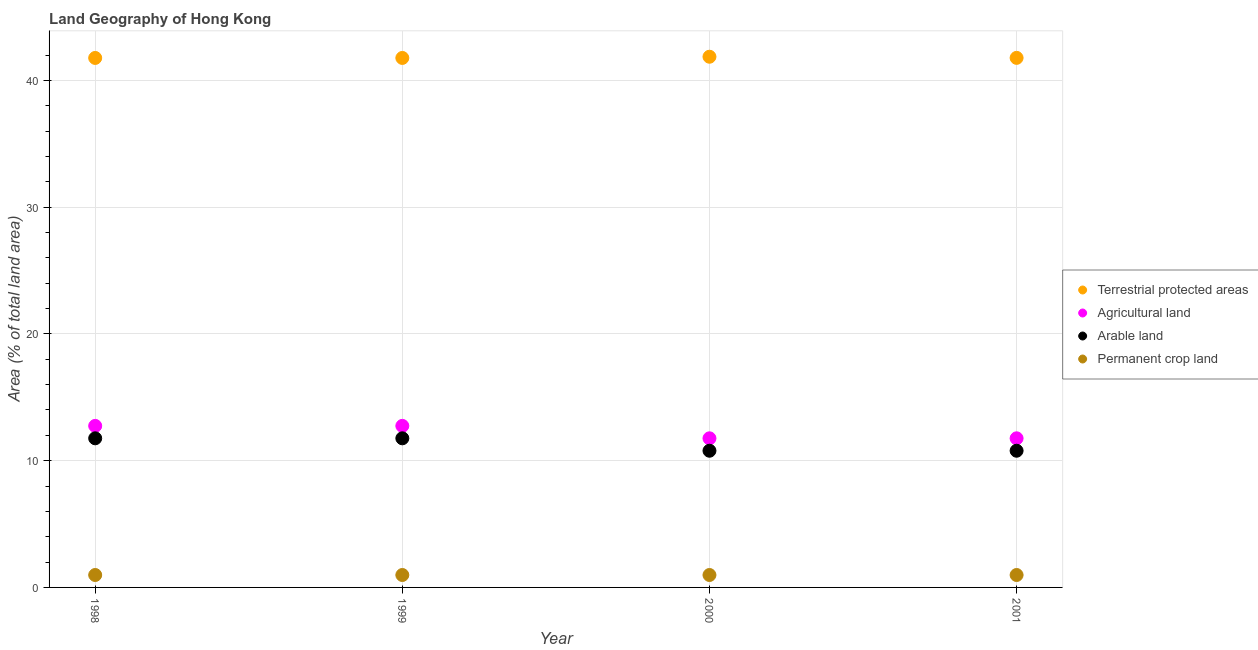How many different coloured dotlines are there?
Your response must be concise. 4. What is the percentage of area under permanent crop land in 1998?
Keep it short and to the point. 0.98. Across all years, what is the maximum percentage of area under permanent crop land?
Make the answer very short. 0.98. Across all years, what is the minimum percentage of area under arable land?
Keep it short and to the point. 10.78. What is the total percentage of area under arable land in the graph?
Offer a terse response. 45.1. What is the difference between the percentage of area under arable land in 2000 and that in 2001?
Your response must be concise. 0. What is the difference between the percentage of area under agricultural land in 2001 and the percentage of area under arable land in 1999?
Provide a succinct answer. 0. What is the average percentage of area under permanent crop land per year?
Provide a succinct answer. 0.98. In the year 2001, what is the difference between the percentage of land under terrestrial protection and percentage of area under permanent crop land?
Offer a very short reply. 40.8. Is the percentage of area under agricultural land in 1999 less than that in 2000?
Make the answer very short. No. Is the sum of the percentage of area under permanent crop land in 1998 and 1999 greater than the maximum percentage of area under arable land across all years?
Provide a succinct answer. No. Does the percentage of land under terrestrial protection monotonically increase over the years?
Your answer should be very brief. No. Is the percentage of area under agricultural land strictly greater than the percentage of area under arable land over the years?
Give a very brief answer. Yes. Is the percentage of area under permanent crop land strictly less than the percentage of area under arable land over the years?
Give a very brief answer. Yes. How many dotlines are there?
Keep it short and to the point. 4. Are the values on the major ticks of Y-axis written in scientific E-notation?
Provide a succinct answer. No. What is the title of the graph?
Offer a terse response. Land Geography of Hong Kong. What is the label or title of the X-axis?
Your answer should be very brief. Year. What is the label or title of the Y-axis?
Ensure brevity in your answer.  Area (% of total land area). What is the Area (% of total land area) in Terrestrial protected areas in 1998?
Offer a terse response. 41.77. What is the Area (% of total land area) of Agricultural land in 1998?
Offer a terse response. 12.75. What is the Area (% of total land area) in Arable land in 1998?
Give a very brief answer. 11.76. What is the Area (% of total land area) of Permanent crop land in 1998?
Provide a short and direct response. 0.98. What is the Area (% of total land area) in Terrestrial protected areas in 1999?
Your answer should be very brief. 41.77. What is the Area (% of total land area) in Agricultural land in 1999?
Your response must be concise. 12.75. What is the Area (% of total land area) in Arable land in 1999?
Offer a terse response. 11.76. What is the Area (% of total land area) of Permanent crop land in 1999?
Ensure brevity in your answer.  0.98. What is the Area (% of total land area) of Terrestrial protected areas in 2000?
Offer a terse response. 41.87. What is the Area (% of total land area) of Agricultural land in 2000?
Your response must be concise. 11.76. What is the Area (% of total land area) of Arable land in 2000?
Your answer should be compact. 10.78. What is the Area (% of total land area) in Permanent crop land in 2000?
Ensure brevity in your answer.  0.98. What is the Area (% of total land area) in Terrestrial protected areas in 2001?
Provide a succinct answer. 41.78. What is the Area (% of total land area) in Agricultural land in 2001?
Offer a terse response. 11.76. What is the Area (% of total land area) in Arable land in 2001?
Offer a very short reply. 10.78. What is the Area (% of total land area) in Permanent crop land in 2001?
Provide a short and direct response. 0.98. Across all years, what is the maximum Area (% of total land area) of Terrestrial protected areas?
Ensure brevity in your answer.  41.87. Across all years, what is the maximum Area (% of total land area) of Agricultural land?
Your answer should be compact. 12.75. Across all years, what is the maximum Area (% of total land area) in Arable land?
Keep it short and to the point. 11.76. Across all years, what is the maximum Area (% of total land area) of Permanent crop land?
Provide a short and direct response. 0.98. Across all years, what is the minimum Area (% of total land area) in Terrestrial protected areas?
Ensure brevity in your answer.  41.77. Across all years, what is the minimum Area (% of total land area) of Agricultural land?
Your answer should be compact. 11.76. Across all years, what is the minimum Area (% of total land area) in Arable land?
Your response must be concise. 10.78. Across all years, what is the minimum Area (% of total land area) in Permanent crop land?
Make the answer very short. 0.98. What is the total Area (% of total land area) of Terrestrial protected areas in the graph?
Keep it short and to the point. 167.2. What is the total Area (% of total land area) of Agricultural land in the graph?
Make the answer very short. 49.02. What is the total Area (% of total land area) of Arable land in the graph?
Ensure brevity in your answer.  45.1. What is the total Area (% of total land area) of Permanent crop land in the graph?
Your answer should be very brief. 3.92. What is the difference between the Area (% of total land area) in Terrestrial protected areas in 1998 and that in 2000?
Your answer should be compact. -0.1. What is the difference between the Area (% of total land area) in Agricultural land in 1998 and that in 2000?
Ensure brevity in your answer.  0.98. What is the difference between the Area (% of total land area) in Arable land in 1998 and that in 2000?
Offer a terse response. 0.98. What is the difference between the Area (% of total land area) of Terrestrial protected areas in 1998 and that in 2001?
Provide a short and direct response. -0.01. What is the difference between the Area (% of total land area) of Agricultural land in 1998 and that in 2001?
Ensure brevity in your answer.  0.98. What is the difference between the Area (% of total land area) of Arable land in 1998 and that in 2001?
Provide a short and direct response. 0.98. What is the difference between the Area (% of total land area) in Terrestrial protected areas in 1999 and that in 2000?
Ensure brevity in your answer.  -0.1. What is the difference between the Area (% of total land area) in Agricultural land in 1999 and that in 2000?
Provide a short and direct response. 0.98. What is the difference between the Area (% of total land area) in Arable land in 1999 and that in 2000?
Make the answer very short. 0.98. What is the difference between the Area (% of total land area) of Terrestrial protected areas in 1999 and that in 2001?
Your response must be concise. -0.01. What is the difference between the Area (% of total land area) in Agricultural land in 1999 and that in 2001?
Provide a short and direct response. 0.98. What is the difference between the Area (% of total land area) in Arable land in 1999 and that in 2001?
Give a very brief answer. 0.98. What is the difference between the Area (% of total land area) of Terrestrial protected areas in 2000 and that in 2001?
Make the answer very short. 0.09. What is the difference between the Area (% of total land area) in Agricultural land in 2000 and that in 2001?
Your response must be concise. 0. What is the difference between the Area (% of total land area) in Arable land in 2000 and that in 2001?
Ensure brevity in your answer.  0. What is the difference between the Area (% of total land area) of Permanent crop land in 2000 and that in 2001?
Provide a succinct answer. 0. What is the difference between the Area (% of total land area) of Terrestrial protected areas in 1998 and the Area (% of total land area) of Agricultural land in 1999?
Your answer should be very brief. 29.03. What is the difference between the Area (% of total land area) of Terrestrial protected areas in 1998 and the Area (% of total land area) of Arable land in 1999?
Provide a succinct answer. 30.01. What is the difference between the Area (% of total land area) of Terrestrial protected areas in 1998 and the Area (% of total land area) of Permanent crop land in 1999?
Provide a succinct answer. 40.79. What is the difference between the Area (% of total land area) in Agricultural land in 1998 and the Area (% of total land area) in Arable land in 1999?
Give a very brief answer. 0.98. What is the difference between the Area (% of total land area) in Agricultural land in 1998 and the Area (% of total land area) in Permanent crop land in 1999?
Your answer should be compact. 11.76. What is the difference between the Area (% of total land area) of Arable land in 1998 and the Area (% of total land area) of Permanent crop land in 1999?
Ensure brevity in your answer.  10.78. What is the difference between the Area (% of total land area) of Terrestrial protected areas in 1998 and the Area (% of total land area) of Agricultural land in 2000?
Provide a short and direct response. 30.01. What is the difference between the Area (% of total land area) of Terrestrial protected areas in 1998 and the Area (% of total land area) of Arable land in 2000?
Provide a succinct answer. 30.99. What is the difference between the Area (% of total land area) in Terrestrial protected areas in 1998 and the Area (% of total land area) in Permanent crop land in 2000?
Your answer should be very brief. 40.79. What is the difference between the Area (% of total land area) of Agricultural land in 1998 and the Area (% of total land area) of Arable land in 2000?
Keep it short and to the point. 1.96. What is the difference between the Area (% of total land area) of Agricultural land in 1998 and the Area (% of total land area) of Permanent crop land in 2000?
Keep it short and to the point. 11.76. What is the difference between the Area (% of total land area) of Arable land in 1998 and the Area (% of total land area) of Permanent crop land in 2000?
Provide a short and direct response. 10.78. What is the difference between the Area (% of total land area) of Terrestrial protected areas in 1998 and the Area (% of total land area) of Agricultural land in 2001?
Your response must be concise. 30.01. What is the difference between the Area (% of total land area) in Terrestrial protected areas in 1998 and the Area (% of total land area) in Arable land in 2001?
Provide a succinct answer. 30.99. What is the difference between the Area (% of total land area) of Terrestrial protected areas in 1998 and the Area (% of total land area) of Permanent crop land in 2001?
Offer a very short reply. 40.79. What is the difference between the Area (% of total land area) in Agricultural land in 1998 and the Area (% of total land area) in Arable land in 2001?
Give a very brief answer. 1.96. What is the difference between the Area (% of total land area) of Agricultural land in 1998 and the Area (% of total land area) of Permanent crop land in 2001?
Make the answer very short. 11.76. What is the difference between the Area (% of total land area) of Arable land in 1998 and the Area (% of total land area) of Permanent crop land in 2001?
Provide a short and direct response. 10.78. What is the difference between the Area (% of total land area) in Terrestrial protected areas in 1999 and the Area (% of total land area) in Agricultural land in 2000?
Offer a terse response. 30.01. What is the difference between the Area (% of total land area) of Terrestrial protected areas in 1999 and the Area (% of total land area) of Arable land in 2000?
Ensure brevity in your answer.  30.99. What is the difference between the Area (% of total land area) in Terrestrial protected areas in 1999 and the Area (% of total land area) in Permanent crop land in 2000?
Give a very brief answer. 40.79. What is the difference between the Area (% of total land area) of Agricultural land in 1999 and the Area (% of total land area) of Arable land in 2000?
Your answer should be very brief. 1.96. What is the difference between the Area (% of total land area) in Agricultural land in 1999 and the Area (% of total land area) in Permanent crop land in 2000?
Ensure brevity in your answer.  11.76. What is the difference between the Area (% of total land area) in Arable land in 1999 and the Area (% of total land area) in Permanent crop land in 2000?
Give a very brief answer. 10.78. What is the difference between the Area (% of total land area) in Terrestrial protected areas in 1999 and the Area (% of total land area) in Agricultural land in 2001?
Provide a short and direct response. 30.01. What is the difference between the Area (% of total land area) of Terrestrial protected areas in 1999 and the Area (% of total land area) of Arable land in 2001?
Offer a very short reply. 30.99. What is the difference between the Area (% of total land area) of Terrestrial protected areas in 1999 and the Area (% of total land area) of Permanent crop land in 2001?
Offer a very short reply. 40.79. What is the difference between the Area (% of total land area) of Agricultural land in 1999 and the Area (% of total land area) of Arable land in 2001?
Your answer should be very brief. 1.96. What is the difference between the Area (% of total land area) in Agricultural land in 1999 and the Area (% of total land area) in Permanent crop land in 2001?
Your response must be concise. 11.76. What is the difference between the Area (% of total land area) in Arable land in 1999 and the Area (% of total land area) in Permanent crop land in 2001?
Your answer should be very brief. 10.78. What is the difference between the Area (% of total land area) in Terrestrial protected areas in 2000 and the Area (% of total land area) in Agricultural land in 2001?
Provide a short and direct response. 30.11. What is the difference between the Area (% of total land area) in Terrestrial protected areas in 2000 and the Area (% of total land area) in Arable land in 2001?
Offer a very short reply. 31.09. What is the difference between the Area (% of total land area) in Terrestrial protected areas in 2000 and the Area (% of total land area) in Permanent crop land in 2001?
Give a very brief answer. 40.89. What is the difference between the Area (% of total land area) of Agricultural land in 2000 and the Area (% of total land area) of Arable land in 2001?
Give a very brief answer. 0.98. What is the difference between the Area (% of total land area) of Agricultural land in 2000 and the Area (% of total land area) of Permanent crop land in 2001?
Keep it short and to the point. 10.78. What is the difference between the Area (% of total land area) in Arable land in 2000 and the Area (% of total land area) in Permanent crop land in 2001?
Ensure brevity in your answer.  9.8. What is the average Area (% of total land area) in Terrestrial protected areas per year?
Your answer should be very brief. 41.8. What is the average Area (% of total land area) of Agricultural land per year?
Make the answer very short. 12.25. What is the average Area (% of total land area) in Arable land per year?
Ensure brevity in your answer.  11.27. What is the average Area (% of total land area) in Permanent crop land per year?
Your answer should be very brief. 0.98. In the year 1998, what is the difference between the Area (% of total land area) in Terrestrial protected areas and Area (% of total land area) in Agricultural land?
Keep it short and to the point. 29.03. In the year 1998, what is the difference between the Area (% of total land area) of Terrestrial protected areas and Area (% of total land area) of Arable land?
Give a very brief answer. 30.01. In the year 1998, what is the difference between the Area (% of total land area) in Terrestrial protected areas and Area (% of total land area) in Permanent crop land?
Your answer should be very brief. 40.79. In the year 1998, what is the difference between the Area (% of total land area) in Agricultural land and Area (% of total land area) in Arable land?
Make the answer very short. 0.98. In the year 1998, what is the difference between the Area (% of total land area) in Agricultural land and Area (% of total land area) in Permanent crop land?
Provide a short and direct response. 11.76. In the year 1998, what is the difference between the Area (% of total land area) of Arable land and Area (% of total land area) of Permanent crop land?
Your answer should be very brief. 10.78. In the year 1999, what is the difference between the Area (% of total land area) of Terrestrial protected areas and Area (% of total land area) of Agricultural land?
Your response must be concise. 29.03. In the year 1999, what is the difference between the Area (% of total land area) in Terrestrial protected areas and Area (% of total land area) in Arable land?
Offer a terse response. 30.01. In the year 1999, what is the difference between the Area (% of total land area) in Terrestrial protected areas and Area (% of total land area) in Permanent crop land?
Your answer should be very brief. 40.79. In the year 1999, what is the difference between the Area (% of total land area) of Agricultural land and Area (% of total land area) of Arable land?
Provide a succinct answer. 0.98. In the year 1999, what is the difference between the Area (% of total land area) of Agricultural land and Area (% of total land area) of Permanent crop land?
Your answer should be very brief. 11.76. In the year 1999, what is the difference between the Area (% of total land area) in Arable land and Area (% of total land area) in Permanent crop land?
Provide a succinct answer. 10.78. In the year 2000, what is the difference between the Area (% of total land area) in Terrestrial protected areas and Area (% of total land area) in Agricultural land?
Offer a very short reply. 30.11. In the year 2000, what is the difference between the Area (% of total land area) of Terrestrial protected areas and Area (% of total land area) of Arable land?
Offer a terse response. 31.09. In the year 2000, what is the difference between the Area (% of total land area) in Terrestrial protected areas and Area (% of total land area) in Permanent crop land?
Keep it short and to the point. 40.89. In the year 2000, what is the difference between the Area (% of total land area) in Agricultural land and Area (% of total land area) in Arable land?
Your answer should be compact. 0.98. In the year 2000, what is the difference between the Area (% of total land area) of Agricultural land and Area (% of total land area) of Permanent crop land?
Your answer should be very brief. 10.78. In the year 2000, what is the difference between the Area (% of total land area) in Arable land and Area (% of total land area) in Permanent crop land?
Your answer should be compact. 9.8. In the year 2001, what is the difference between the Area (% of total land area) of Terrestrial protected areas and Area (% of total land area) of Agricultural land?
Give a very brief answer. 30.02. In the year 2001, what is the difference between the Area (% of total land area) of Terrestrial protected areas and Area (% of total land area) of Arable land?
Give a very brief answer. 31. In the year 2001, what is the difference between the Area (% of total land area) of Terrestrial protected areas and Area (% of total land area) of Permanent crop land?
Give a very brief answer. 40.8. In the year 2001, what is the difference between the Area (% of total land area) of Agricultural land and Area (% of total land area) of Arable land?
Your answer should be very brief. 0.98. In the year 2001, what is the difference between the Area (% of total land area) in Agricultural land and Area (% of total land area) in Permanent crop land?
Provide a succinct answer. 10.78. In the year 2001, what is the difference between the Area (% of total land area) in Arable land and Area (% of total land area) in Permanent crop land?
Provide a short and direct response. 9.8. What is the ratio of the Area (% of total land area) of Agricultural land in 1998 to that in 1999?
Provide a short and direct response. 1. What is the ratio of the Area (% of total land area) of Arable land in 1998 to that in 1999?
Provide a succinct answer. 1. What is the ratio of the Area (% of total land area) in Terrestrial protected areas in 1998 to that in 2000?
Keep it short and to the point. 1. What is the ratio of the Area (% of total land area) in Agricultural land in 1998 to that in 2000?
Give a very brief answer. 1.08. What is the ratio of the Area (% of total land area) of Arable land in 1998 to that in 2000?
Ensure brevity in your answer.  1.09. What is the ratio of the Area (% of total land area) of Permanent crop land in 1998 to that in 2001?
Give a very brief answer. 1. What is the ratio of the Area (% of total land area) of Agricultural land in 1999 to that in 2001?
Your response must be concise. 1.08. What is the ratio of the Area (% of total land area) in Arable land in 1999 to that in 2001?
Your response must be concise. 1.09. What is the ratio of the Area (% of total land area) of Terrestrial protected areas in 2000 to that in 2001?
Give a very brief answer. 1. What is the ratio of the Area (% of total land area) of Agricultural land in 2000 to that in 2001?
Provide a short and direct response. 1. What is the ratio of the Area (% of total land area) in Permanent crop land in 2000 to that in 2001?
Your answer should be very brief. 1. What is the difference between the highest and the second highest Area (% of total land area) in Terrestrial protected areas?
Your answer should be very brief. 0.09. What is the difference between the highest and the second highest Area (% of total land area) of Agricultural land?
Make the answer very short. 0. What is the difference between the highest and the lowest Area (% of total land area) of Terrestrial protected areas?
Offer a terse response. 0.1. What is the difference between the highest and the lowest Area (% of total land area) of Agricultural land?
Offer a terse response. 0.98. What is the difference between the highest and the lowest Area (% of total land area) in Arable land?
Your response must be concise. 0.98. What is the difference between the highest and the lowest Area (% of total land area) of Permanent crop land?
Provide a short and direct response. 0. 